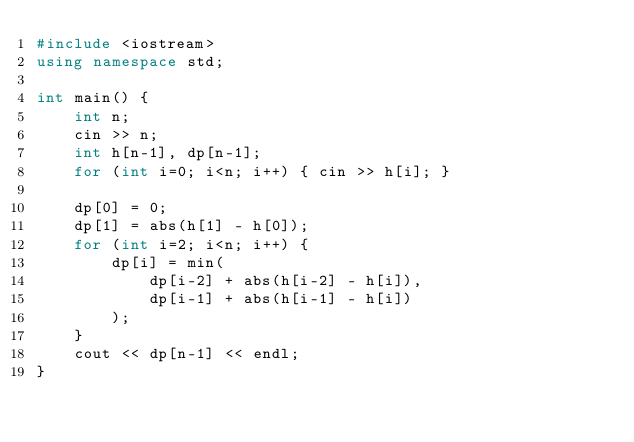<code> <loc_0><loc_0><loc_500><loc_500><_C++_>#include <iostream>
using namespace std;

int main() {
	int n;
    cin >> n;
    int h[n-1], dp[n-1];
    for (int i=0; i<n; i++) { cin >> h[i]; }

    dp[0] = 0;
    dp[1] = abs(h[1] - h[0]);
    for (int i=2; i<n; i++) {
        dp[i] = min(
            dp[i-2] + abs(h[i-2] - h[i]),
            dp[i-1] + abs(h[i-1] - h[i])
        );
    }
    cout << dp[n-1] << endl;
}</code> 